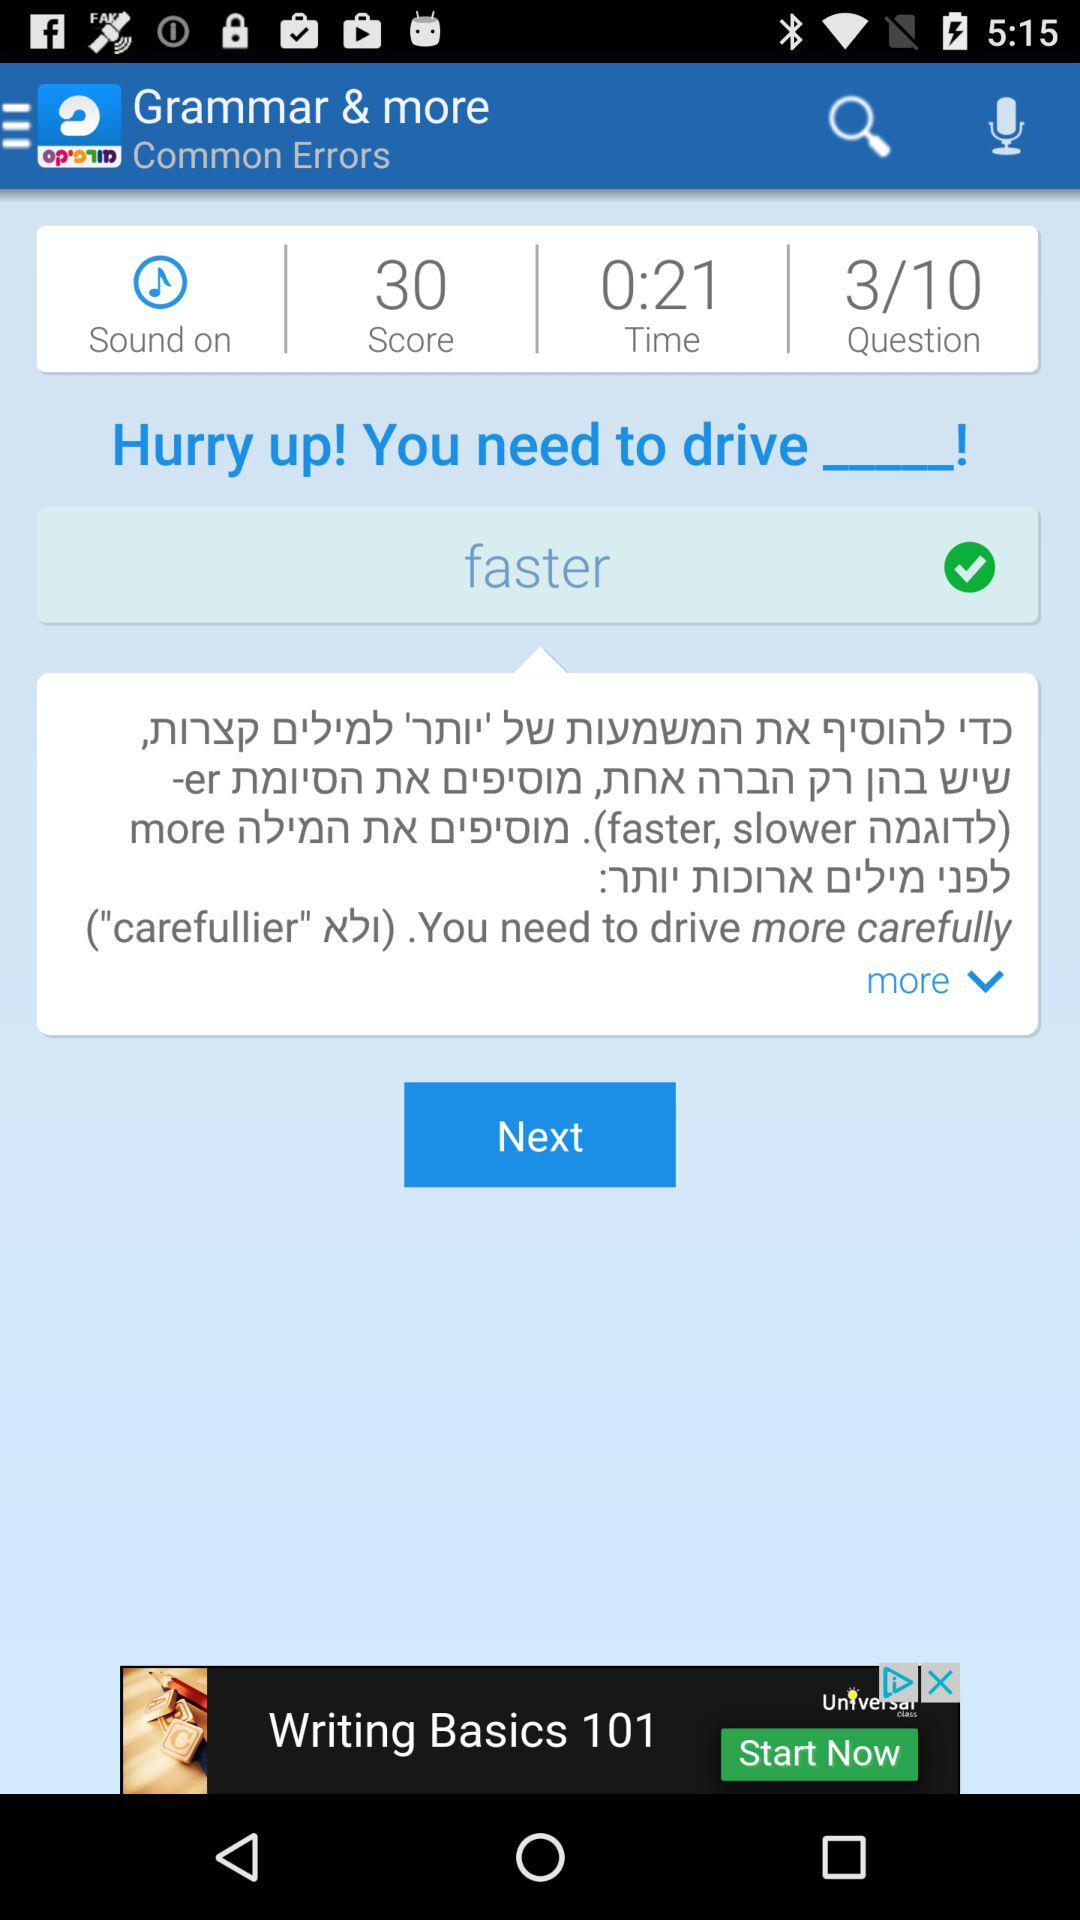What is the total score? The total score is 30. 